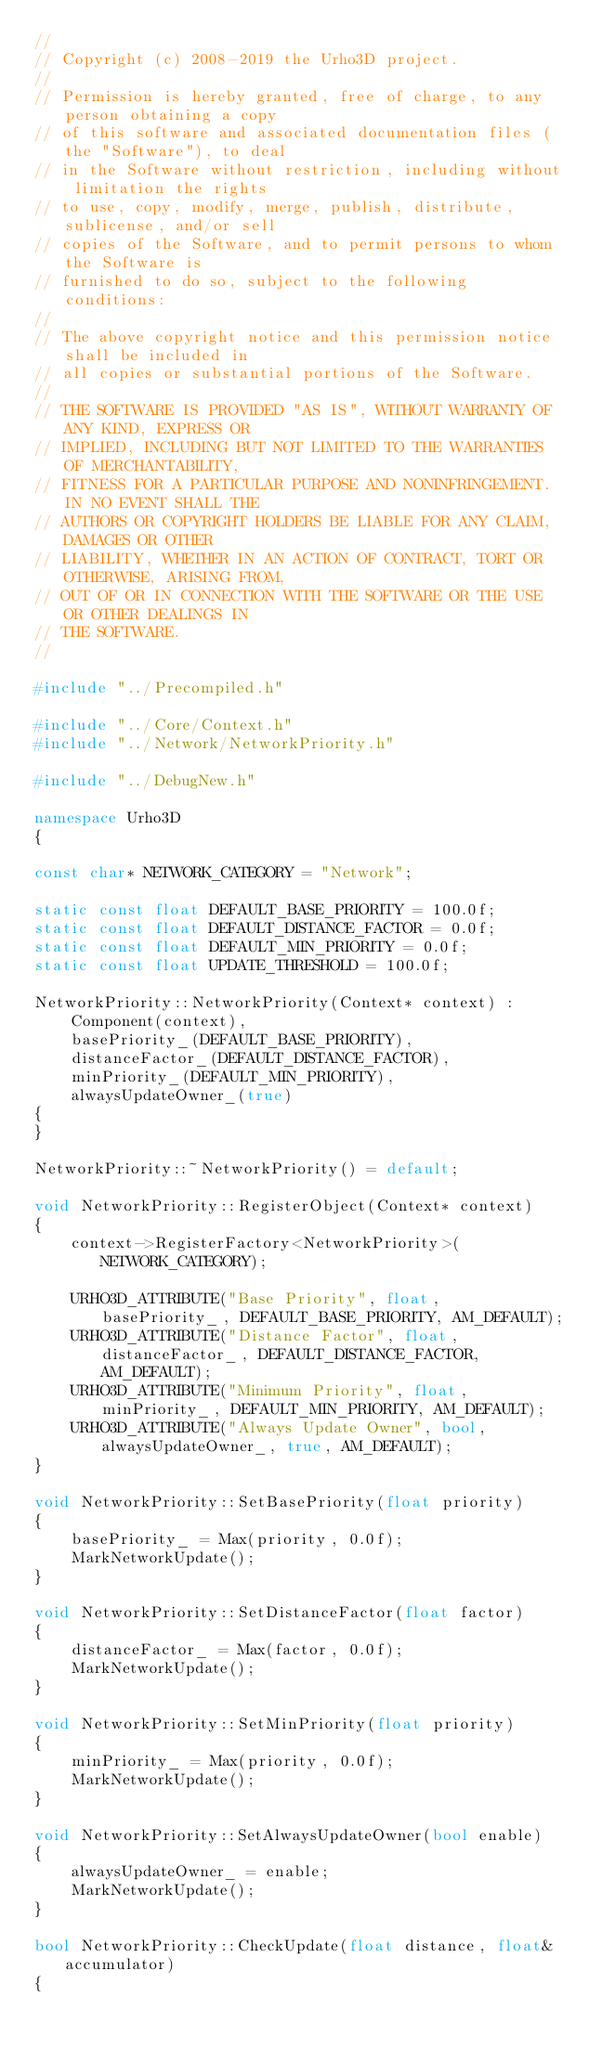Convert code to text. <code><loc_0><loc_0><loc_500><loc_500><_C++_>//
// Copyright (c) 2008-2019 the Urho3D project.
//
// Permission is hereby granted, free of charge, to any person obtaining a copy
// of this software and associated documentation files (the "Software"), to deal
// in the Software without restriction, including without limitation the rights
// to use, copy, modify, merge, publish, distribute, sublicense, and/or sell
// copies of the Software, and to permit persons to whom the Software is
// furnished to do so, subject to the following conditions:
//
// The above copyright notice and this permission notice shall be included in
// all copies or substantial portions of the Software.
//
// THE SOFTWARE IS PROVIDED "AS IS", WITHOUT WARRANTY OF ANY KIND, EXPRESS OR
// IMPLIED, INCLUDING BUT NOT LIMITED TO THE WARRANTIES OF MERCHANTABILITY,
// FITNESS FOR A PARTICULAR PURPOSE AND NONINFRINGEMENT. IN NO EVENT SHALL THE
// AUTHORS OR COPYRIGHT HOLDERS BE LIABLE FOR ANY CLAIM, DAMAGES OR OTHER
// LIABILITY, WHETHER IN AN ACTION OF CONTRACT, TORT OR OTHERWISE, ARISING FROM,
// OUT OF OR IN CONNECTION WITH THE SOFTWARE OR THE USE OR OTHER DEALINGS IN
// THE SOFTWARE.
//

#include "../Precompiled.h"

#include "../Core/Context.h"
#include "../Network/NetworkPriority.h"

#include "../DebugNew.h"

namespace Urho3D
{

const char* NETWORK_CATEGORY = "Network";

static const float DEFAULT_BASE_PRIORITY = 100.0f;
static const float DEFAULT_DISTANCE_FACTOR = 0.0f;
static const float DEFAULT_MIN_PRIORITY = 0.0f;
static const float UPDATE_THRESHOLD = 100.0f;

NetworkPriority::NetworkPriority(Context* context) :
    Component(context),
    basePriority_(DEFAULT_BASE_PRIORITY),
    distanceFactor_(DEFAULT_DISTANCE_FACTOR),
    minPriority_(DEFAULT_MIN_PRIORITY),
    alwaysUpdateOwner_(true)
{
}

NetworkPriority::~NetworkPriority() = default;

void NetworkPriority::RegisterObject(Context* context)
{
    context->RegisterFactory<NetworkPriority>(NETWORK_CATEGORY);

    URHO3D_ATTRIBUTE("Base Priority", float, basePriority_, DEFAULT_BASE_PRIORITY, AM_DEFAULT);
    URHO3D_ATTRIBUTE("Distance Factor", float, distanceFactor_, DEFAULT_DISTANCE_FACTOR, AM_DEFAULT);
    URHO3D_ATTRIBUTE("Minimum Priority", float, minPriority_, DEFAULT_MIN_PRIORITY, AM_DEFAULT);
    URHO3D_ATTRIBUTE("Always Update Owner", bool, alwaysUpdateOwner_, true, AM_DEFAULT);
}

void NetworkPriority::SetBasePriority(float priority)
{
    basePriority_ = Max(priority, 0.0f);
    MarkNetworkUpdate();
}

void NetworkPriority::SetDistanceFactor(float factor)
{
    distanceFactor_ = Max(factor, 0.0f);
    MarkNetworkUpdate();
}

void NetworkPriority::SetMinPriority(float priority)
{
    minPriority_ = Max(priority, 0.0f);
    MarkNetworkUpdate();
}

void NetworkPriority::SetAlwaysUpdateOwner(bool enable)
{
    alwaysUpdateOwner_ = enable;
    MarkNetworkUpdate();
}

bool NetworkPriority::CheckUpdate(float distance, float& accumulator)
{</code> 